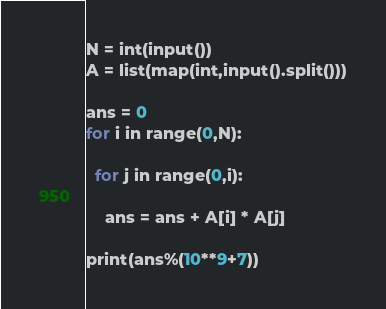<code> <loc_0><loc_0><loc_500><loc_500><_Python_>N = int(input())
A = list(map(int,input().split()))

ans = 0
for i in range(0,N):
  
  for j in range(0,i):
    
    ans = ans + A[i] * A[j]

print(ans%(10**9+7))</code> 